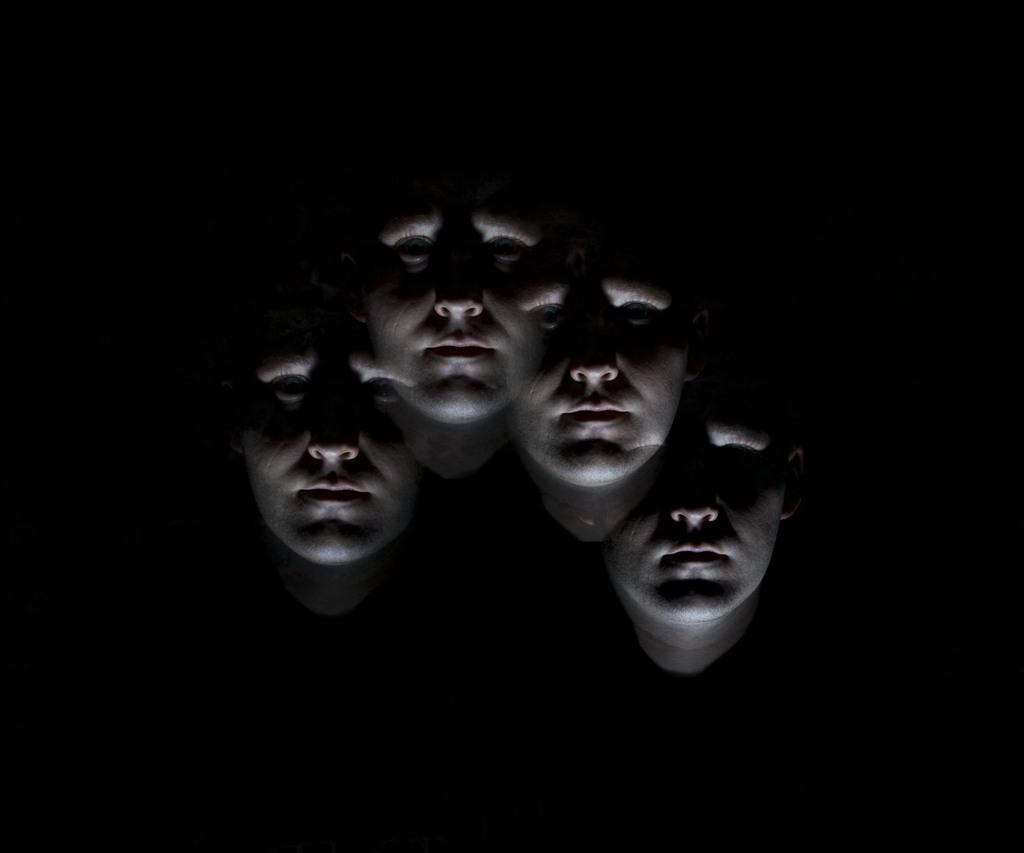What is the main subject of the image? The main subject of the image is an edited picture of a person's face. What color is the background of the image? The background of the image is black. What type of business is being conducted in the image? There is no indication of any business activity in the image, as it features an edited picture of a person's face with a black background. What type of snack is visible in the image? There is no snack, such as popcorn, present in the image. 